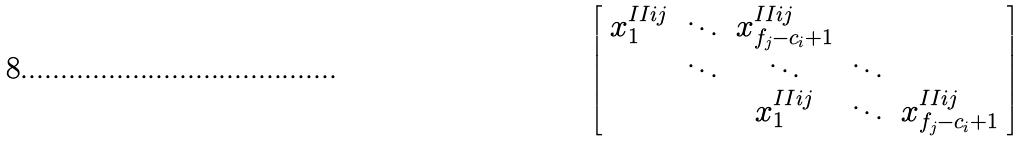<formula> <loc_0><loc_0><loc_500><loc_500>\left [ \begin{array} { c c c c c } x ^ { I I i j } _ { 1 } & \ddots & x ^ { I I i j } _ { f _ { j } - c _ { i } + 1 } & & \\ & \ddots & \ddots & \ddots & \\ & & x ^ { I I i j } _ { 1 } & \ddots & x ^ { I I i j } _ { f _ { j } - c _ { i } + 1 } \end{array} \right ]</formula> 